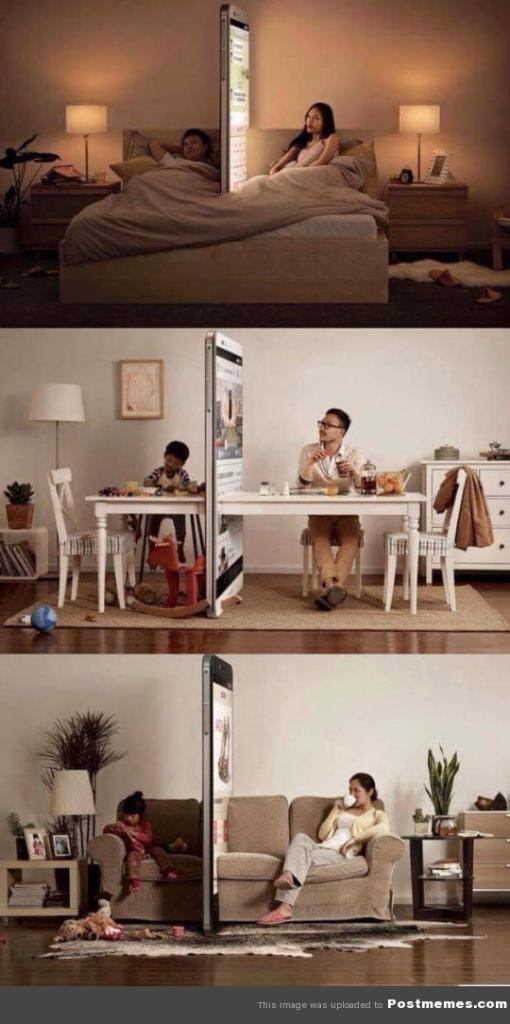Could you give a brief overview of what you see in this image? I see a collage of pics, In which these are sitting on the couch and there are few things on the either side, In this pic these two are sitting on chair and there is a table in front, In the background I see a lamp, a photo frame, cabinet and a plant over here and this pic I see this person is lying and this person is sitting and there are lamps on the either side. 